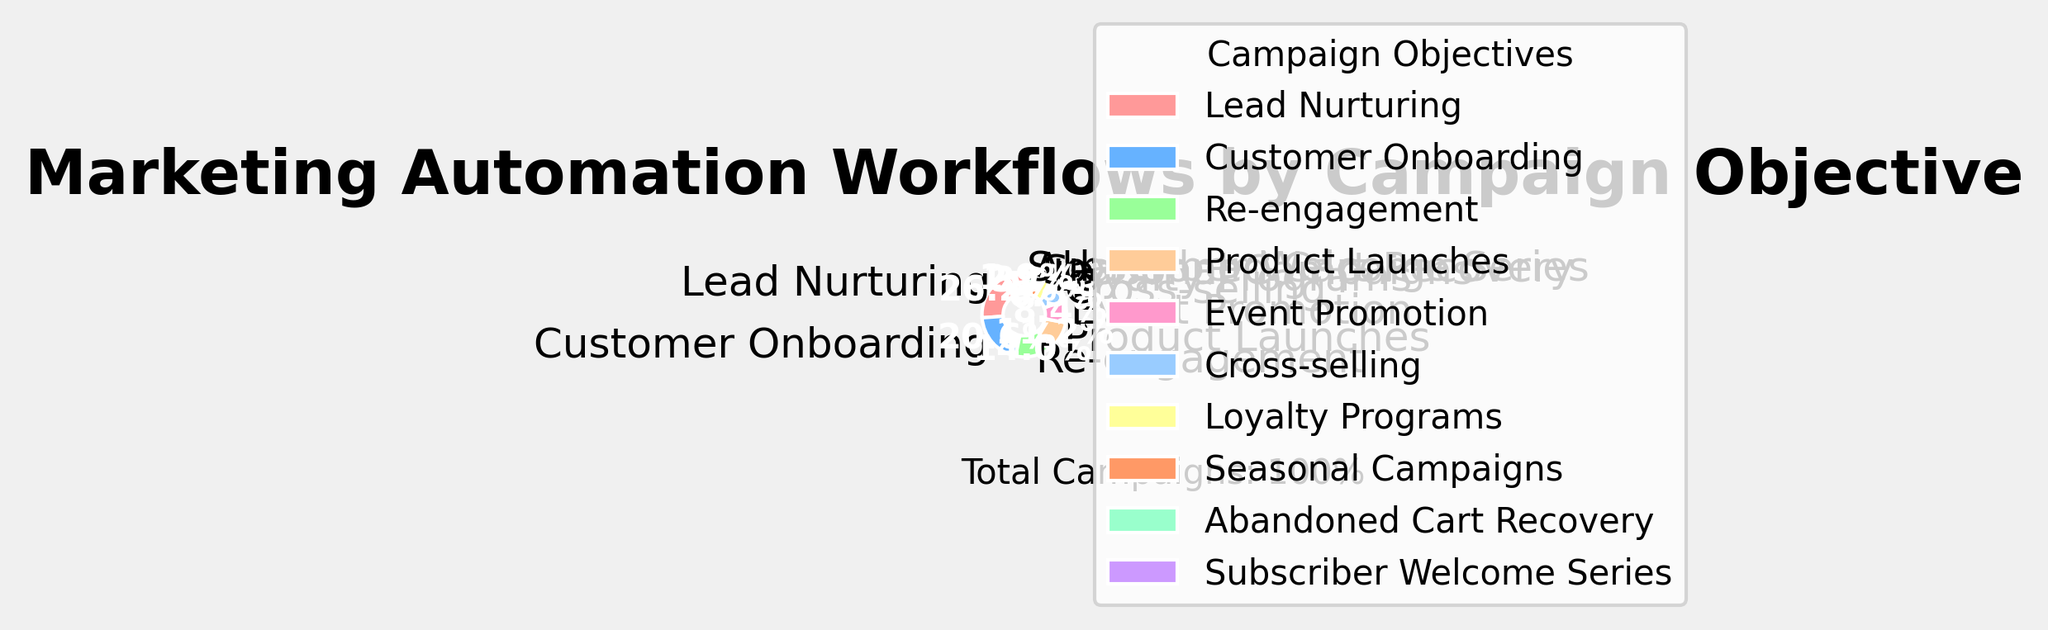What percentage of marketing automation workflows are for Customer Onboarding? The figure labels each slice of the pie chart with its respective campaign objective and percentage. Locate the slice labeled "Customer Onboarding" and read the percentage value.
Answer: 22% How much more common are Lead Nurturing workflows compared to Cross-selling workflows? First, identify the percentage for Lead Nurturing (28%) and Cross-Selling (7%) from the pie chart. Then, calculate the difference: 28% - 7% = 21%.
Answer: 21% Which campaign objective has the lowest percentage, and what is that percentage? Look for the smallest slice of the pie chart, which corresponds to the objective that has the smallest percentage. The label for this slice will show the objective and its percentage.
Answer: Subscriber Welcome Series, 2% Are there more campaigns for Re-engagement or Product Launches, and by what percentage? Identify the percentages for Re-engagement (15%) and Product Launches (12%) from the pie chart. Compare the two values and calculate the difference: 15% - 12% = 3%.
Answer: Re-engagement, 3% What is the combined percentage for Event Promotion, Cross-selling, and Loyalty Programs? Find the percentages for Event Promotion (9%), Cross-selling (7%), and Loyalty Programs (5%) on the pie chart. Add these values together: 9% + 7% + 5% = 21%.
Answer: 21% Which color represents Lead Nurturing campaigns, and what percentage of total campaigns do they represent? The pie chart uses colors to visually differentiate each campaign objective. Identify the color used for the section labeled "Lead Nurturing" and note the percentage indicated on that section.
Answer: Red, 28% Calculate the difference in percentage points between the most and least frequent campaign objectives. Identify the highest percentage (Lead Nurturing at 28%) and the lowest percentage (Subscriber Welcome Series at 2%) from the pie chart. Subtract the smallest value from the largest: 28% - 2% = 26%.
Answer: 26% Which is more common: Seasonal Campaigns or Abandoned Cart Recovery, and by how much? Identify the percentages for Seasonal Campaigns (4%) and Abandoned Cart Recovery (3%) from the pie chart. Compare the two values and calculate the difference: 4% - 3% = 1%.
Answer: Seasonal Campaigns, 1% How many campaign objectives account for more than 10% of the total workflows? Examine the pie chart to see which campaign objectives have a slice larger than 10%. Count these slices.
Answer: 4 What percentage of campaigns are for non-Onboarding objectives? Identify the percentage for Customer Onboarding (22%) and subtract it from 100% to find the sum of all other objectives: 100% - 22% = 78%.
Answer: 78% 